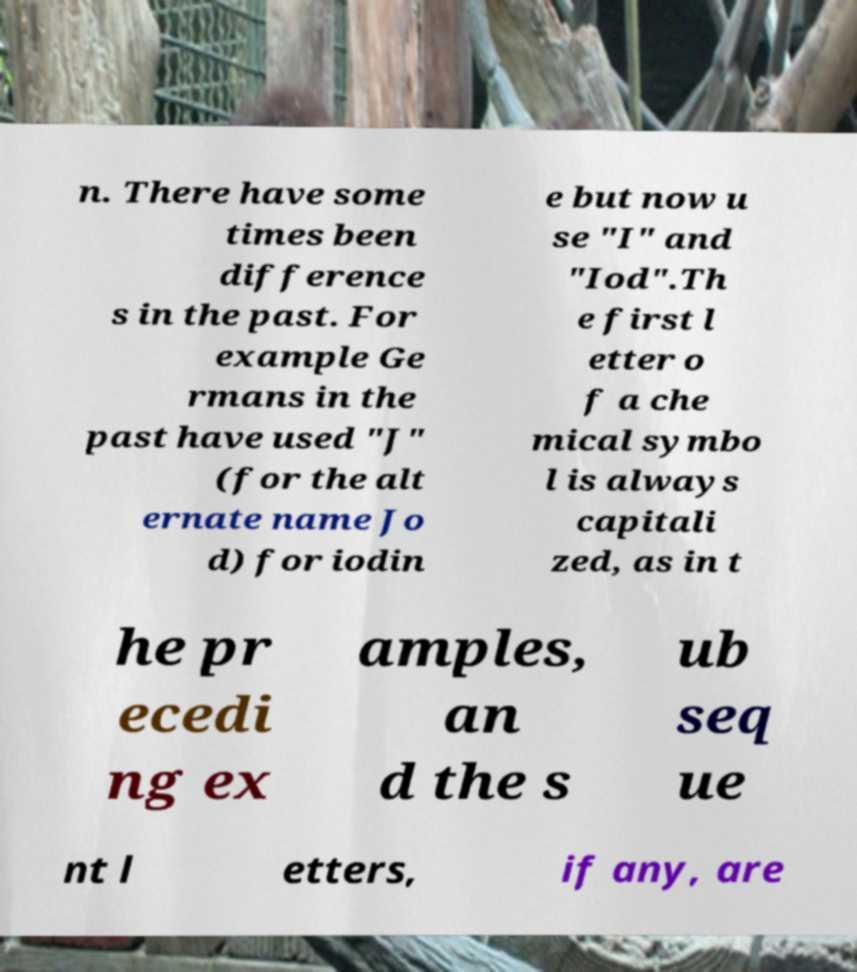Please identify and transcribe the text found in this image. n. There have some times been difference s in the past. For example Ge rmans in the past have used "J" (for the alt ernate name Jo d) for iodin e but now u se "I" and "Iod".Th e first l etter o f a che mical symbo l is always capitali zed, as in t he pr ecedi ng ex amples, an d the s ub seq ue nt l etters, if any, are 